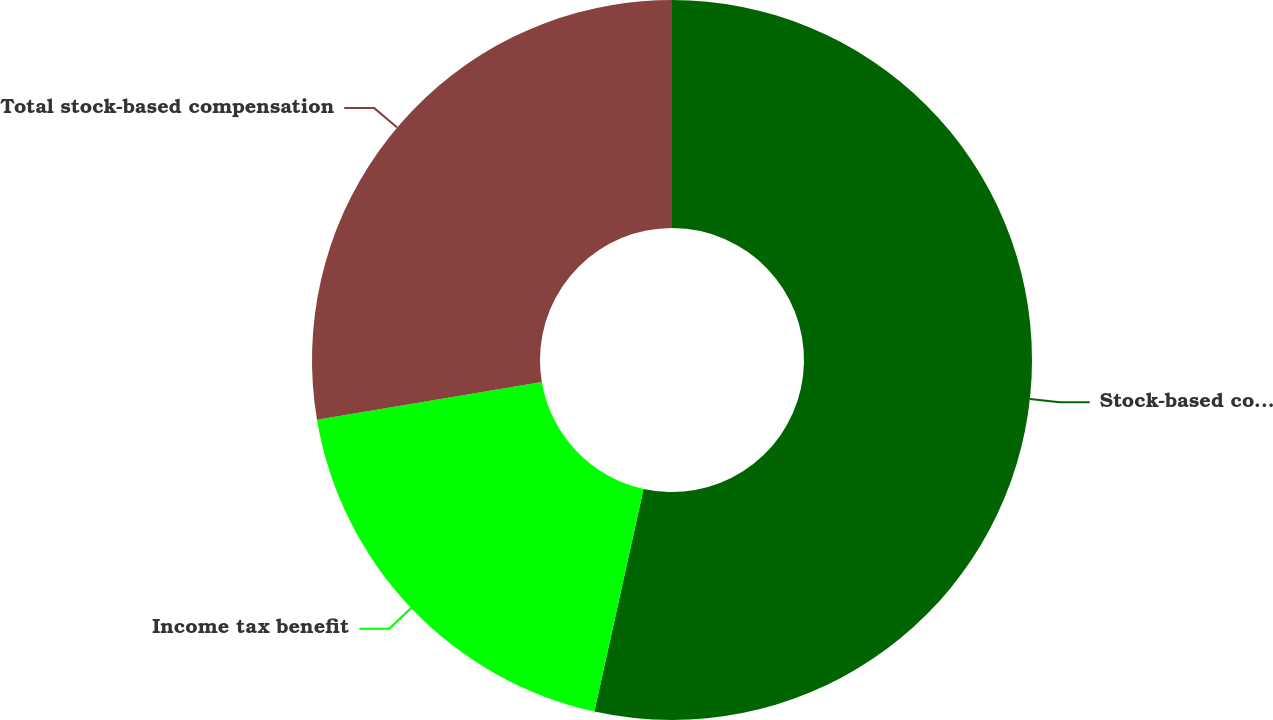Convert chart. <chart><loc_0><loc_0><loc_500><loc_500><pie_chart><fcel>Stock-based compensation plans<fcel>Income tax benefit<fcel>Total stock-based compensation<nl><fcel>53.46%<fcel>18.89%<fcel>27.65%<nl></chart> 